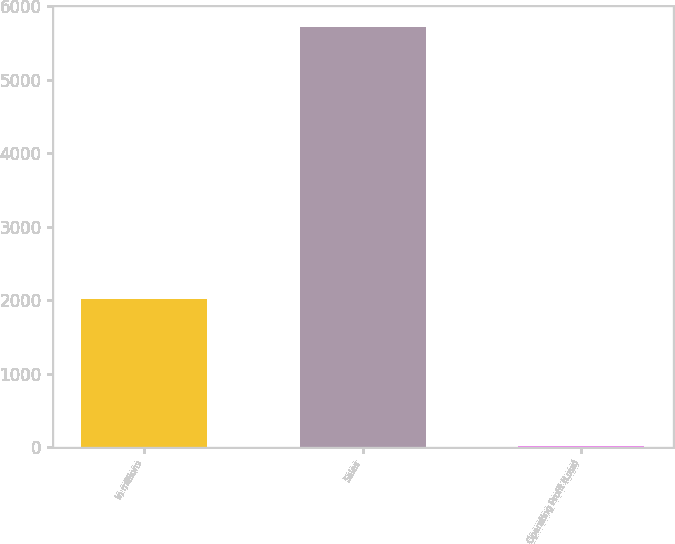<chart> <loc_0><loc_0><loc_500><loc_500><bar_chart><fcel>In millions<fcel>Sales<fcel>Operating Profit (Loss)<nl><fcel>2014<fcel>5720<fcel>16<nl></chart> 